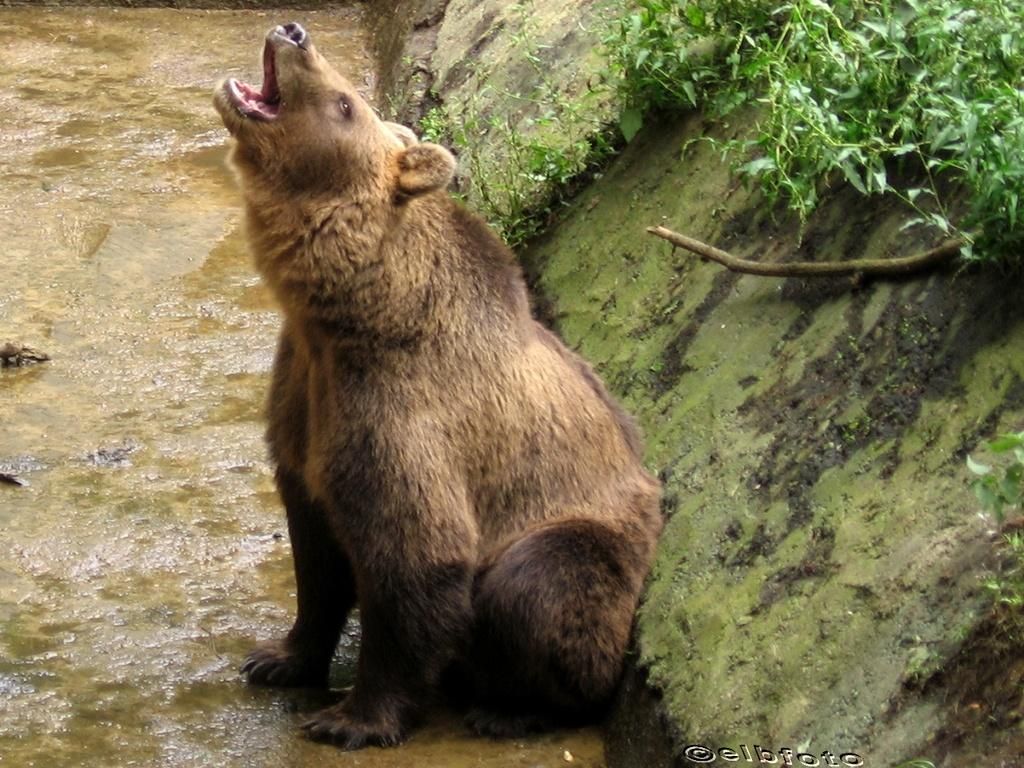What type of animal is in the image? There is a brown color bear in the image. What is on the ground in the image? There is water on the ground in the image. What can be seen at the right side of the image? There is a wall at the right side of the image. What type of vegetation is present in the image? There are green color plants in the image. What type of hill can be seen in the background of the image? There is no hill visible in the image. 